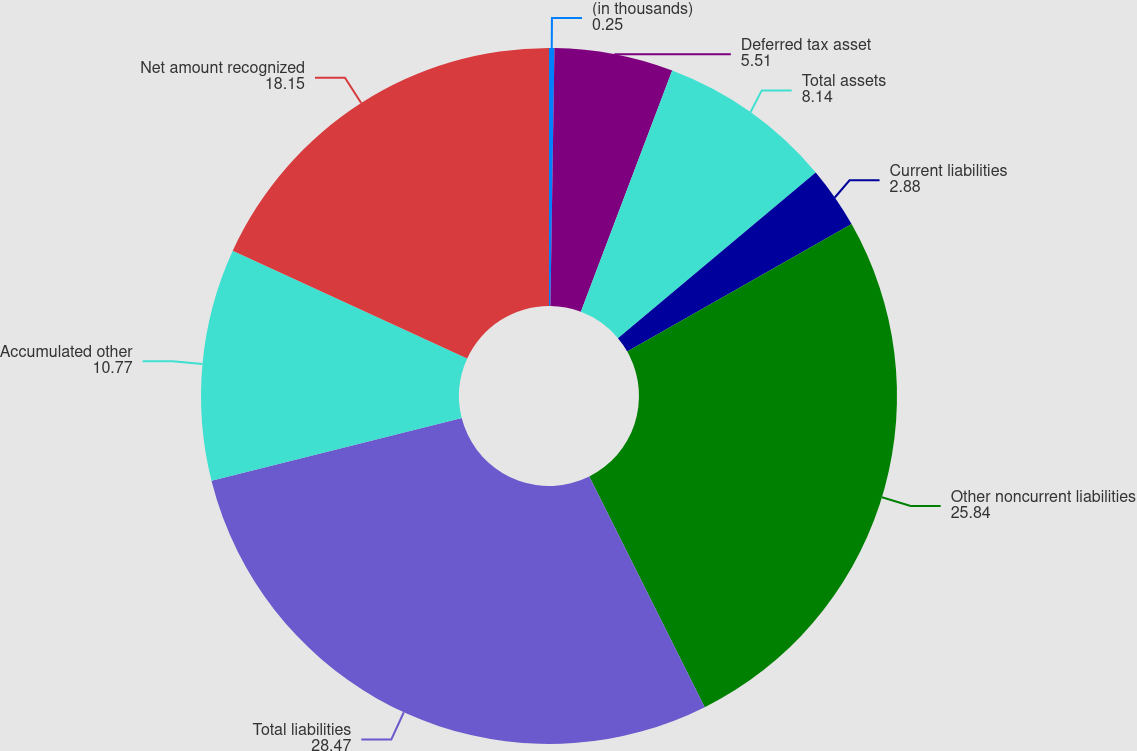Convert chart. <chart><loc_0><loc_0><loc_500><loc_500><pie_chart><fcel>(in thousands)<fcel>Deferred tax asset<fcel>Total assets<fcel>Current liabilities<fcel>Other noncurrent liabilities<fcel>Total liabilities<fcel>Accumulated other<fcel>Net amount recognized<nl><fcel>0.25%<fcel>5.51%<fcel>8.14%<fcel>2.88%<fcel>25.84%<fcel>28.47%<fcel>10.77%<fcel>18.15%<nl></chart> 